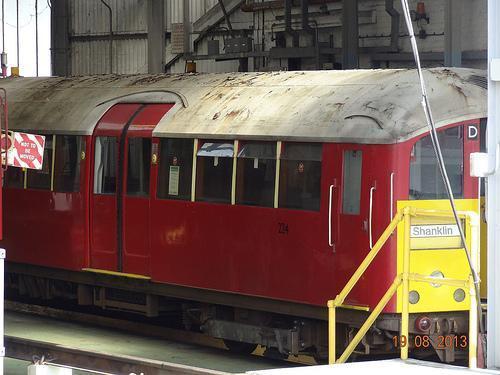How many train cars are in the photo?
Give a very brief answer. 1. 